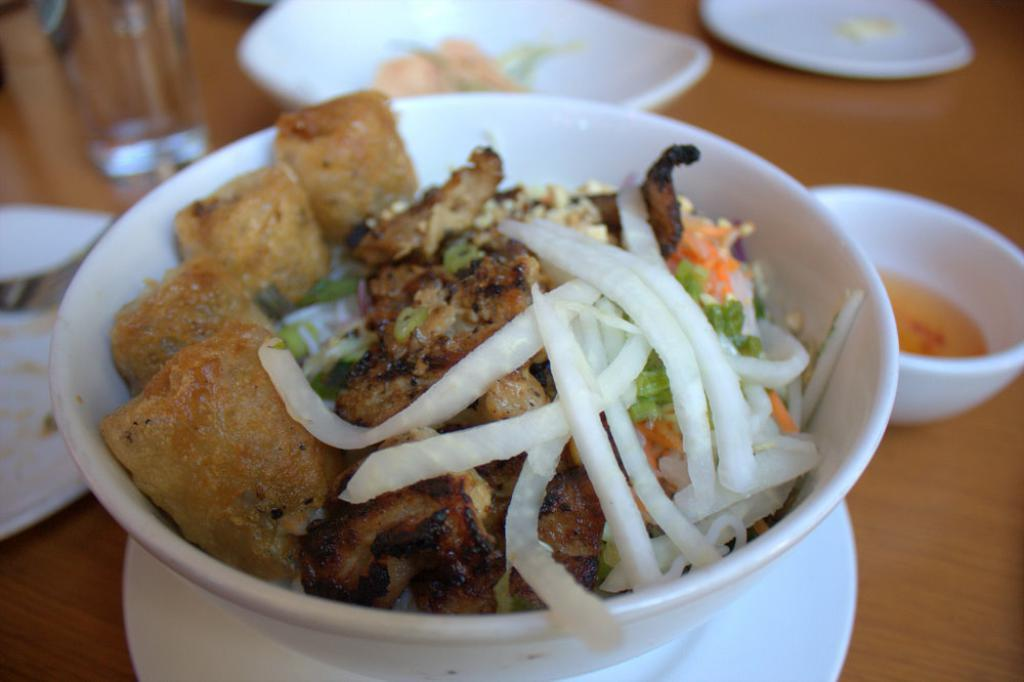What color is the bowl containing the food item in the image? The bowl containing the food item is white. What other tableware can be seen in the image? There are plates visible in the image. What is the color of the table in the image? The table is brown. What colors are present in the food item? The food item has white, brown, green, and orange colors. What type of wound can be seen on the minister in the image? There is no minister or wound present in the image. How can one join the group of people in the image? There is no indication of a group of people or the possibility of joining them in the image. 